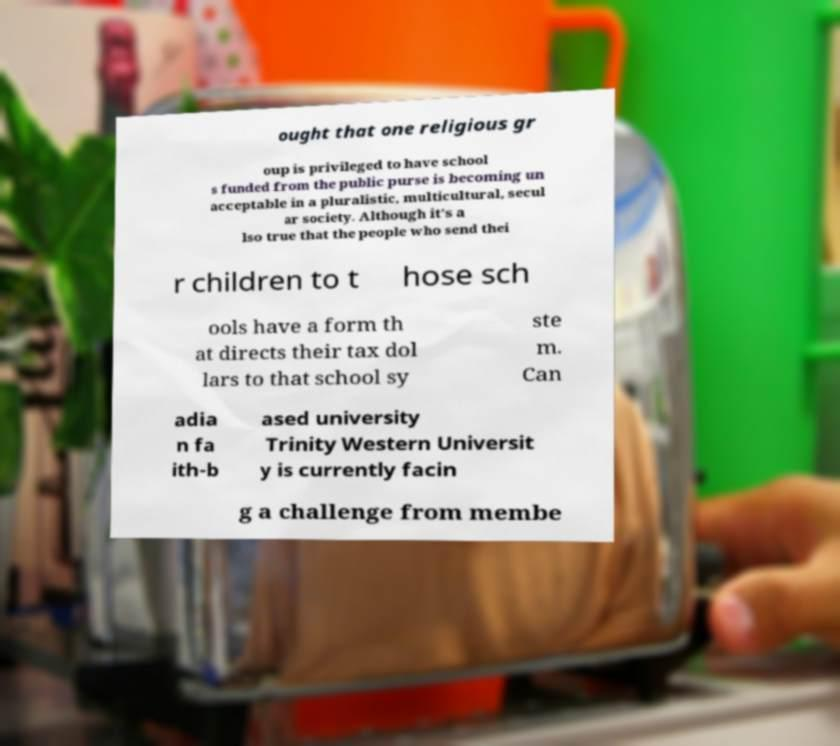Please read and relay the text visible in this image. What does it say? ought that one religious gr oup is privileged to have school s funded from the public purse is becoming un acceptable in a pluralistic, multicultural, secul ar society. Although it's a lso true that the people who send thei r children to t hose sch ools have a form th at directs their tax dol lars to that school sy ste m. Can adia n fa ith-b ased university Trinity Western Universit y is currently facin g a challenge from membe 